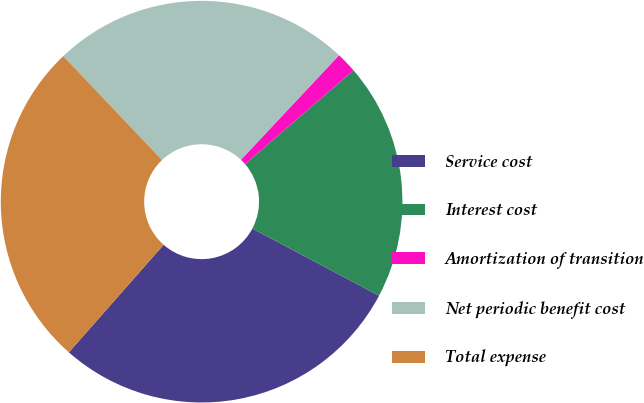Convert chart to OTSL. <chart><loc_0><loc_0><loc_500><loc_500><pie_chart><fcel>Service cost<fcel>Interest cost<fcel>Amortization of transition<fcel>Net periodic benefit cost<fcel>Total expense<nl><fcel>28.74%<fcel>19.1%<fcel>1.66%<fcel>24.09%<fcel>26.41%<nl></chart> 